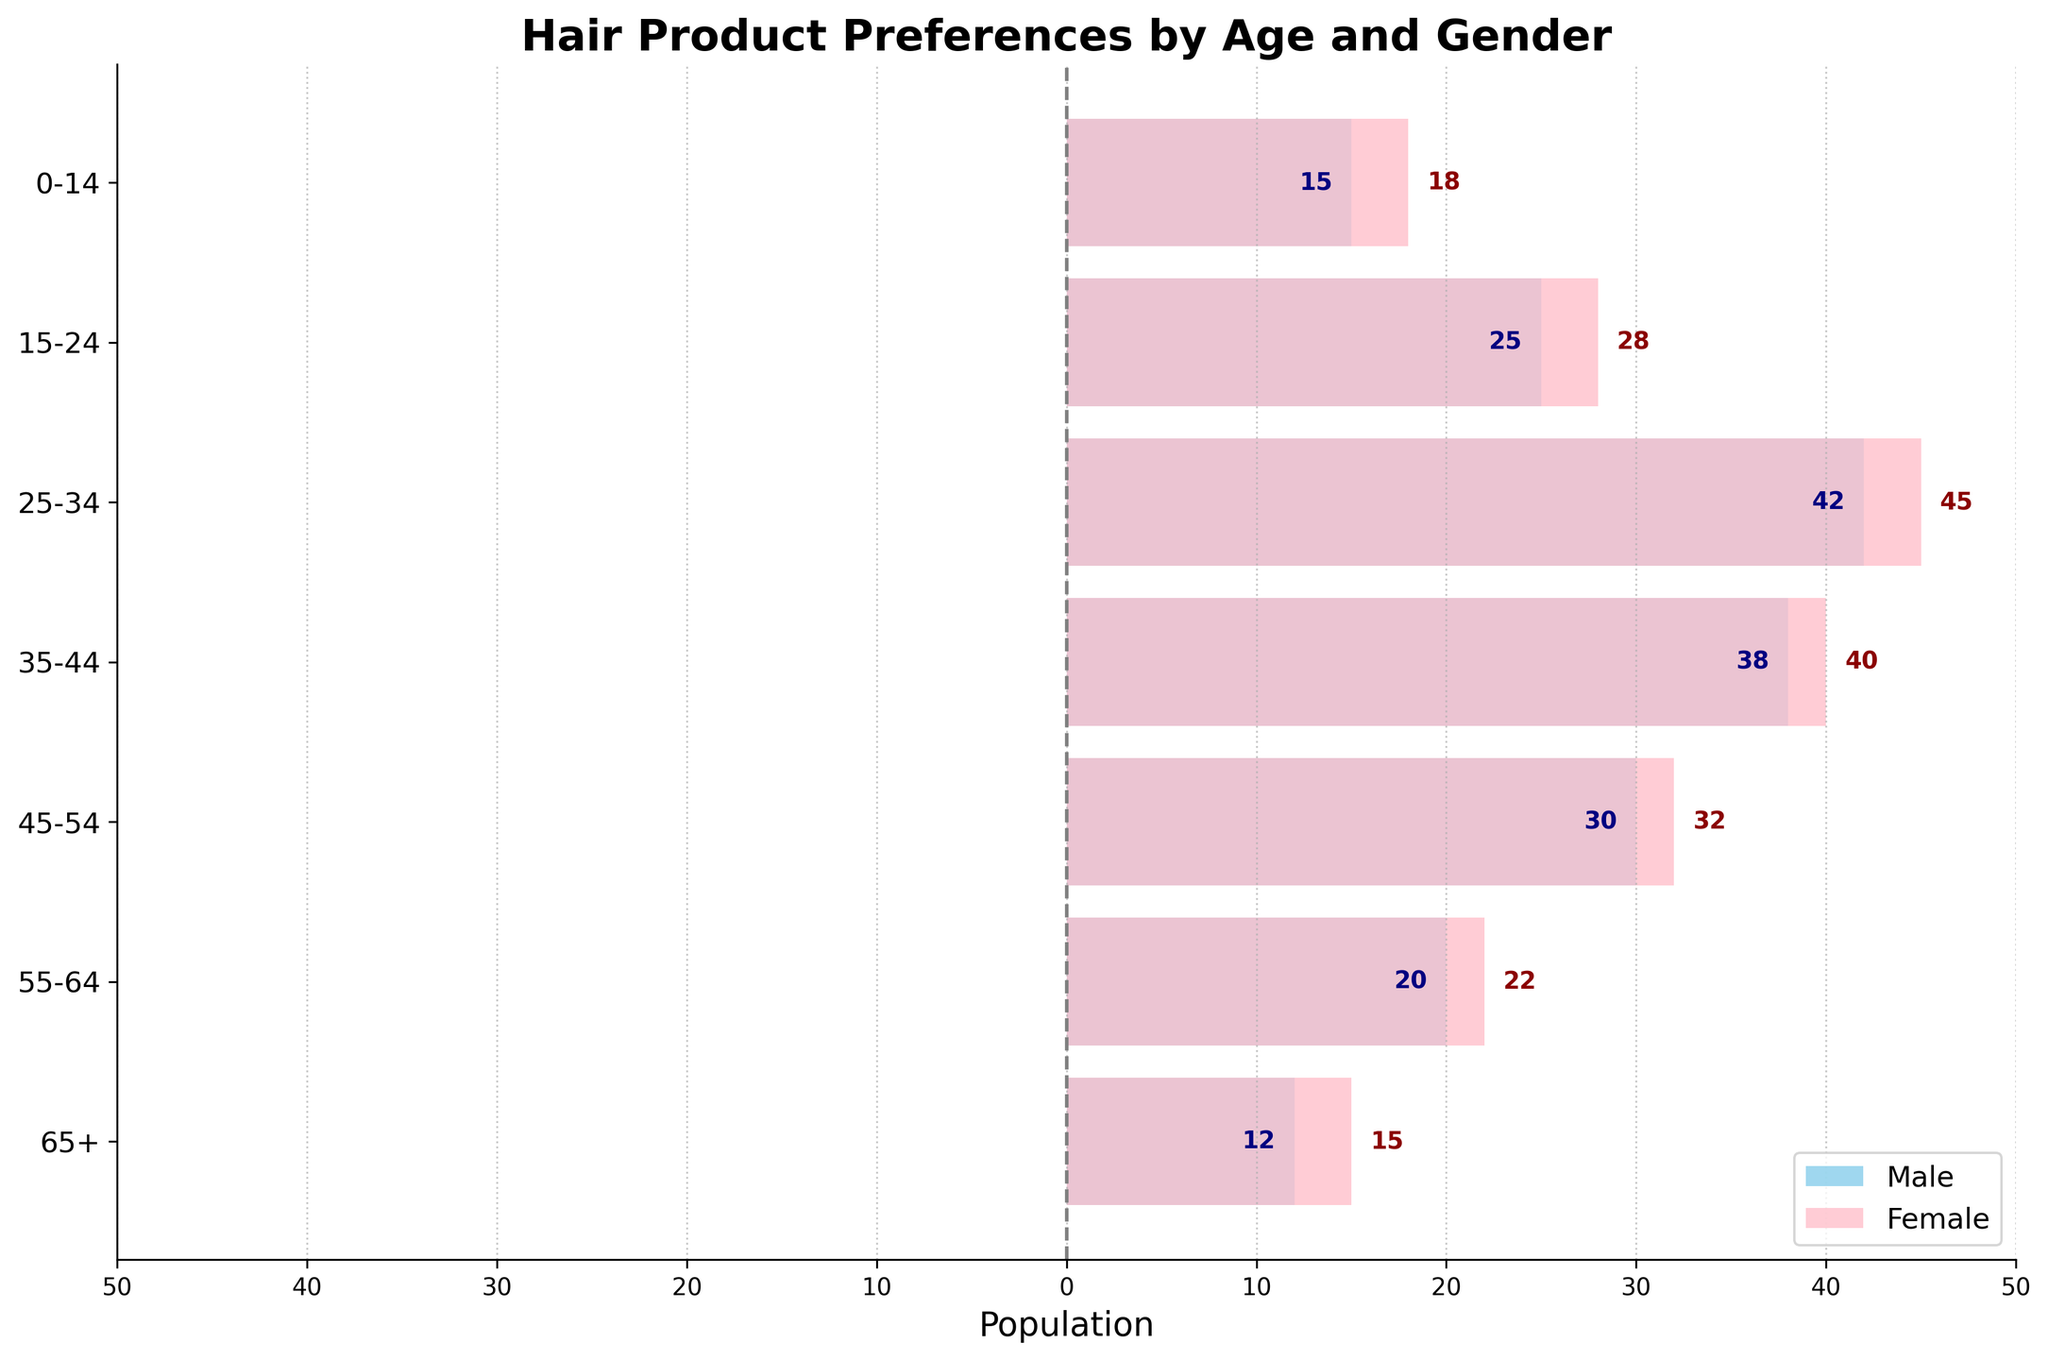What is the title of the chart? The title of the chart is located at the top of the figure and serves as a descriptor of the data being visualized.
Answer: Hair Product Preferences by Age and Gender Which age group has the highest preference for hair products among females? By examining the length of the bars on the right side of the pyramid, we can determine that the 25-34 age group has the highest preference, as it has the longest bar.
Answer: 25-34 What is the total preference for hair products across all age groups for males? Sum the absolute values of the male preferences across all age groups: 15 + 25 + 42 + 38 + 30 + 20 + 12. Adding these together gives 182.
Answer: 182 Compare the hair product preferences between males and females in the 35-44 age group. Which gender prefers them more? Look at the lengths of the bars in the 35-44 age group. The bar for females (right side) is longer than the bar for males (left side), indicating higher preference among females.
Answer: Females In which age group is the male preference for hair products closest to 30? By inspecting the bars on the left side of the pyramid, we can see that the 45-54 age group has a male preference closest to 30, as its corresponding bar represents 30.
Answer: 45-54 What is the difference in hair product preferences between the 15-24 and 55-64 age groups for females? The female preference in the 15-24 age group is 28, and in the 55-64 age group, it is 22. Subtract 22 from 28 to find the difference: 28 - 22 = 6.
Answer: 6 Which age group has the lowest preference for hair products among males? By looking at the lengths of the bars on the left side of the pyramid, we can see that the 65+ age group has the shortest bar, indicating the lowest preference.
Answer: 65+ Which gender has a greater preference for hair products in the 0-14 age group? By how much? The female preference in the 0-14 age group is 18, and the male preference is 15. To find the difference, subtract 15 from 18: 18 - 15 = 3. Females have a greater preference by 3.
Answer: Females, by 3 What is the average female preference for hair products across all age groups? Sum the female preferences across all age groups: 18 + 28 + 45 + 40 + 32 + 22 + 15 = 200. Divide by the number of age groups, which is 7: 200 / 7 ≈ 28.57.
Answer: 28.57 